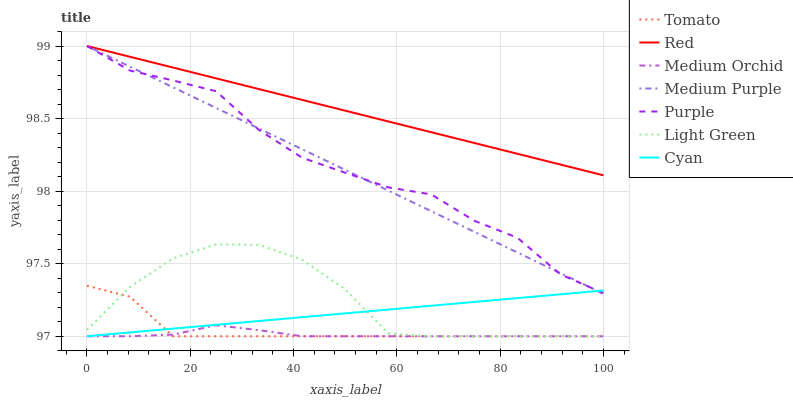Does Purple have the minimum area under the curve?
Answer yes or no. No. Does Purple have the maximum area under the curve?
Answer yes or no. No. Is Medium Orchid the smoothest?
Answer yes or no. No. Is Medium Orchid the roughest?
Answer yes or no. No. Does Purple have the lowest value?
Answer yes or no. No. Does Medium Orchid have the highest value?
Answer yes or no. No. Is Light Green less than Medium Purple?
Answer yes or no. Yes. Is Red greater than Light Green?
Answer yes or no. Yes. Does Light Green intersect Medium Purple?
Answer yes or no. No. 